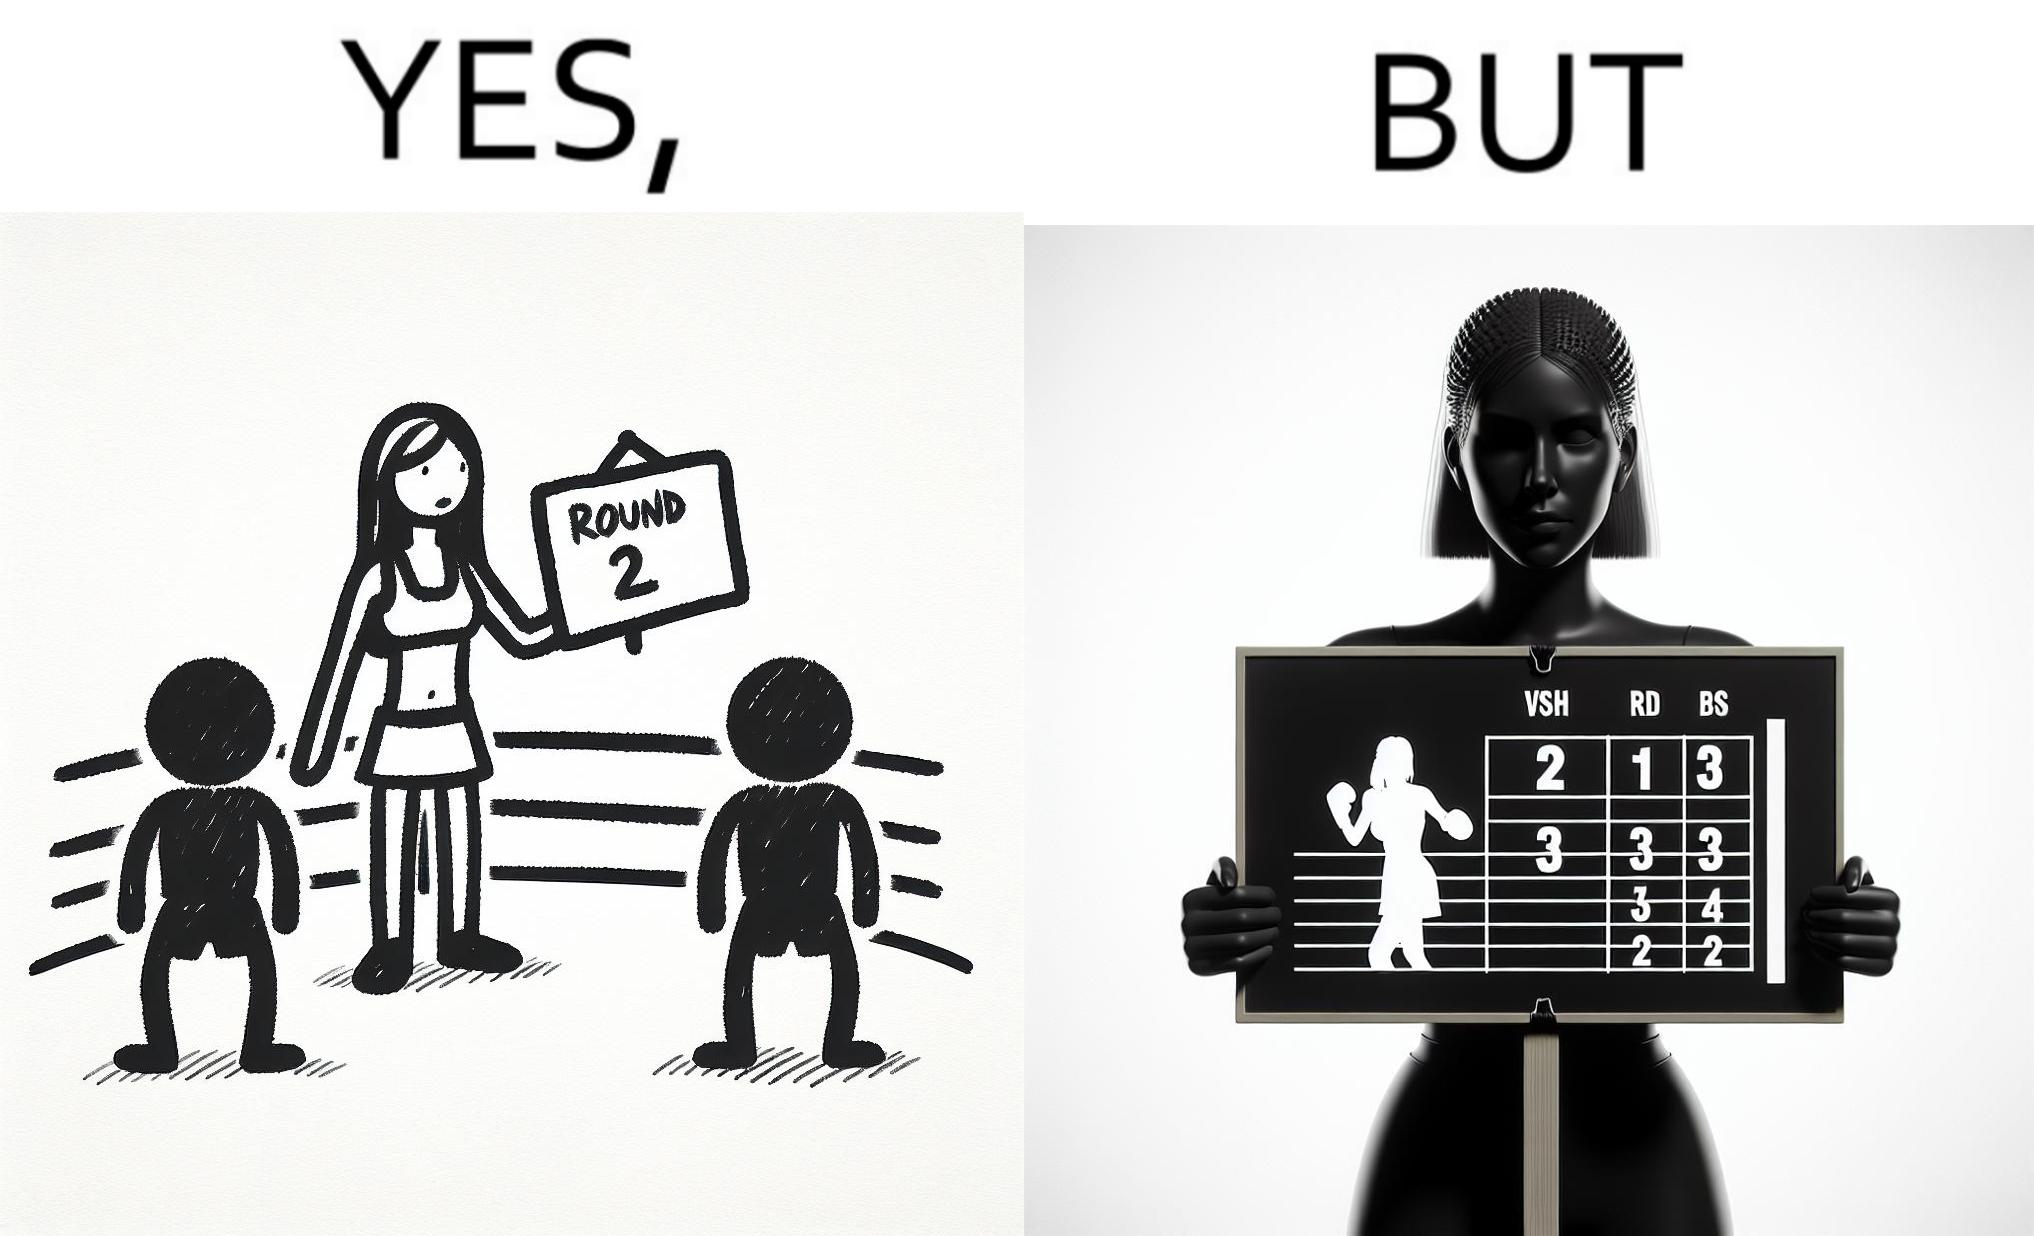What is shown in this image? This is a satirical image with contrasting elements. 